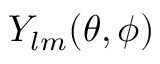<formula> <loc_0><loc_0><loc_500><loc_500>Y _ { l m } ( \theta , \phi )</formula> 